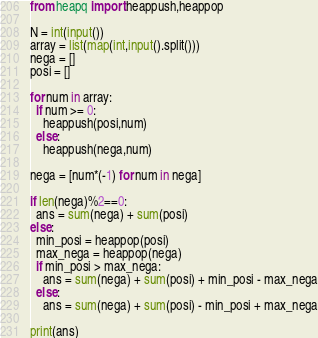Convert code to text. <code><loc_0><loc_0><loc_500><loc_500><_Python_>from heapq import heappush,heappop

N = int(input())
array = list(map(int,input().split()))
nega = []
posi = []

for num in array:
  if num >= 0:
    heappush(posi,num)
  else:
    heappush(nega,num)

nega = [num*(-1) for num in nega]

if len(nega)%2==0:
  ans = sum(nega) + sum(posi)
else:
  min_posi = heappop(posi)
  max_nega = heappop(nega)
  if min_posi > max_nega:
    ans = sum(nega) + sum(posi) + min_posi - max_nega
  else:
    ans = sum(nega) + sum(posi) - min_posi + max_nega
    
print(ans)</code> 